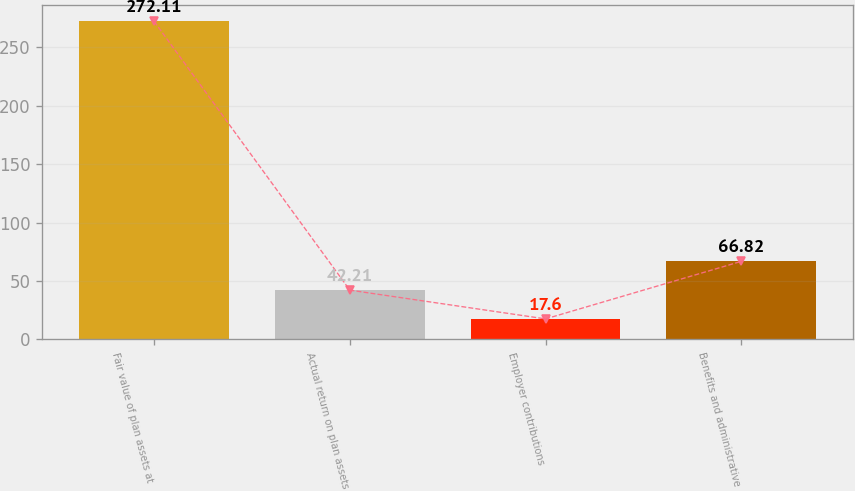Convert chart. <chart><loc_0><loc_0><loc_500><loc_500><bar_chart><fcel>Fair value of plan assets at<fcel>Actual return on plan assets<fcel>Employer contributions<fcel>Benefits and administrative<nl><fcel>272.11<fcel>42.21<fcel>17.6<fcel>66.82<nl></chart> 